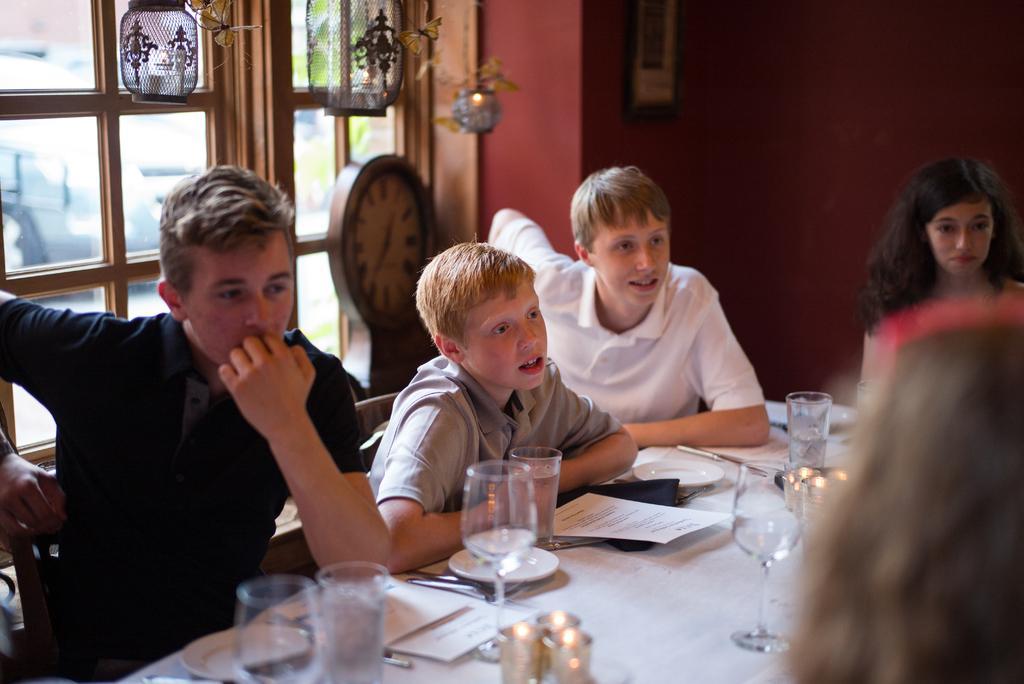Can you describe this image briefly? In this image I see a 3 boys and a woman who are sitting on the chairs and there is a table in front and there are glasses, papers and few things on it. In the background I see the window and the decoration. 